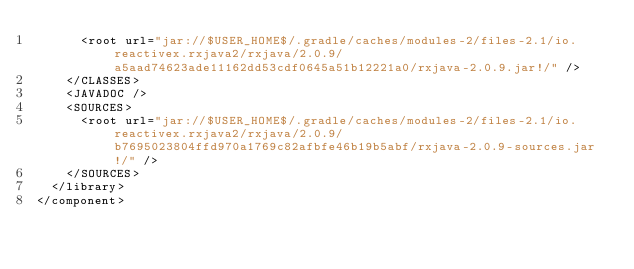Convert code to text. <code><loc_0><loc_0><loc_500><loc_500><_XML_>      <root url="jar://$USER_HOME$/.gradle/caches/modules-2/files-2.1/io.reactivex.rxjava2/rxjava/2.0.9/a5aad74623ade11162dd53cdf0645a51b12221a0/rxjava-2.0.9.jar!/" />
    </CLASSES>
    <JAVADOC />
    <SOURCES>
      <root url="jar://$USER_HOME$/.gradle/caches/modules-2/files-2.1/io.reactivex.rxjava2/rxjava/2.0.9/b7695023804ffd970a1769c82afbfe46b19b5abf/rxjava-2.0.9-sources.jar!/" />
    </SOURCES>
  </library>
</component></code> 